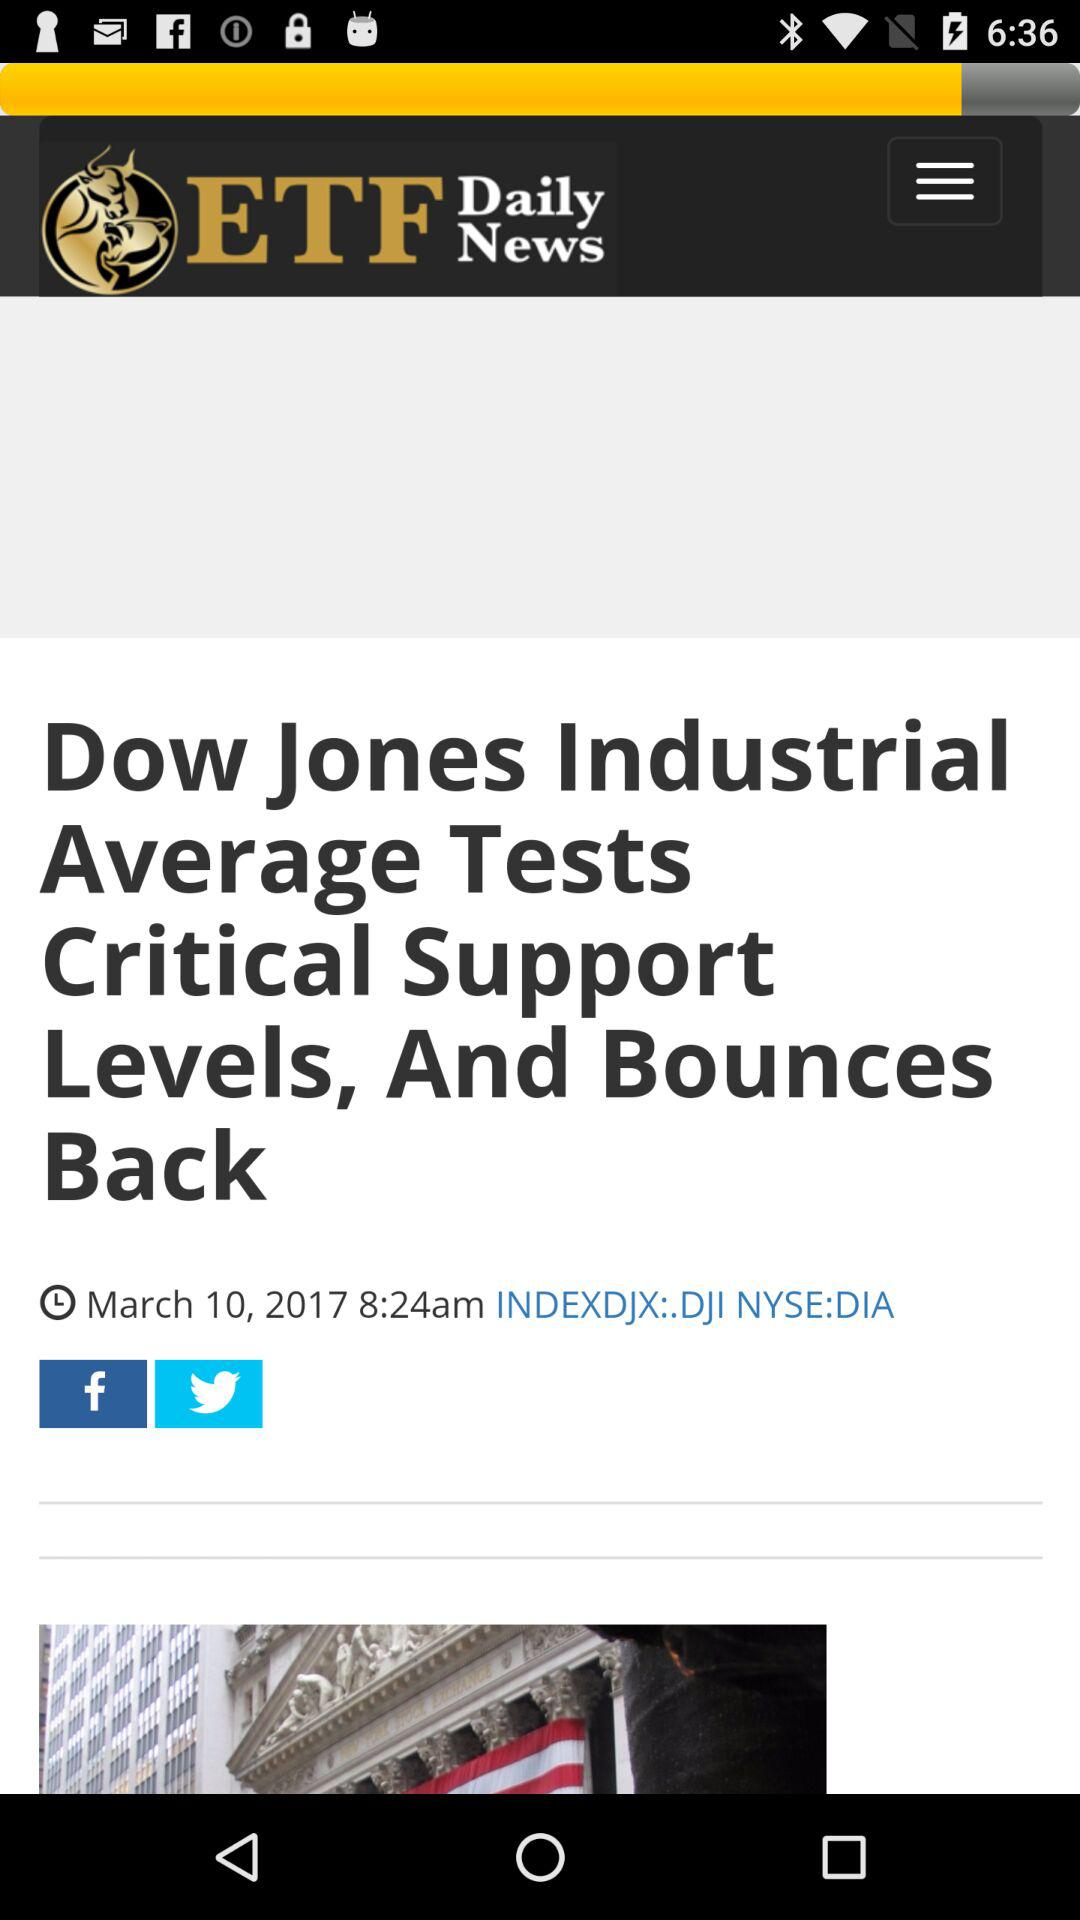What's the article headline? The article headline is "Dow Jones Industrial Average Tests Critical Support Levels, And Bounces Back". 